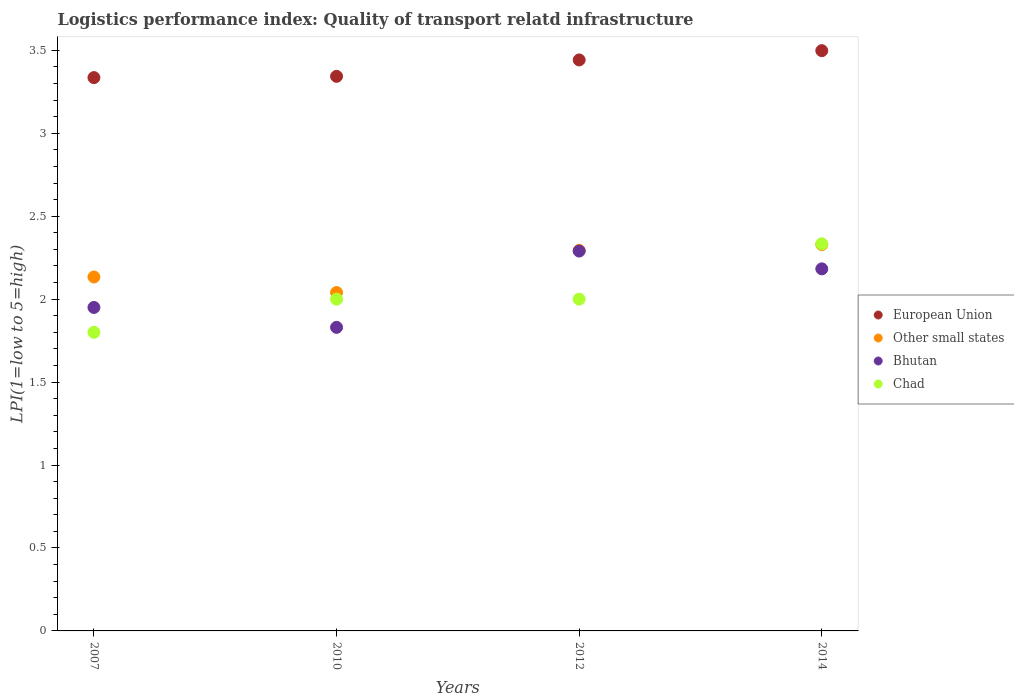How many different coloured dotlines are there?
Your answer should be very brief. 4. What is the logistics performance index in European Union in 2014?
Your answer should be compact. 3.5. Across all years, what is the maximum logistics performance index in Chad?
Keep it short and to the point. 2.33. In which year was the logistics performance index in Bhutan maximum?
Give a very brief answer. 2012. In which year was the logistics performance index in Bhutan minimum?
Provide a short and direct response. 2010. What is the total logistics performance index in European Union in the graph?
Your answer should be very brief. 13.62. What is the difference between the logistics performance index in Chad in 2010 and that in 2014?
Keep it short and to the point. -0.33. What is the difference between the logistics performance index in Bhutan in 2014 and the logistics performance index in Other small states in 2007?
Provide a short and direct response. 0.05. What is the average logistics performance index in Chad per year?
Offer a terse response. 2.03. In the year 2012, what is the difference between the logistics performance index in Other small states and logistics performance index in Bhutan?
Offer a very short reply. 0. What is the ratio of the logistics performance index in Other small states in 2007 to that in 2012?
Your response must be concise. 0.93. Is the logistics performance index in Bhutan in 2012 less than that in 2014?
Ensure brevity in your answer.  No. What is the difference between the highest and the second highest logistics performance index in Chad?
Keep it short and to the point. 0.33. What is the difference between the highest and the lowest logistics performance index in European Union?
Provide a succinct answer. 0.16. In how many years, is the logistics performance index in Chad greater than the average logistics performance index in Chad taken over all years?
Make the answer very short. 1. Is it the case that in every year, the sum of the logistics performance index in Chad and logistics performance index in European Union  is greater than the sum of logistics performance index in Bhutan and logistics performance index in Other small states?
Provide a short and direct response. Yes. Is the logistics performance index in European Union strictly greater than the logistics performance index in Bhutan over the years?
Your response must be concise. Yes. Is the logistics performance index in European Union strictly less than the logistics performance index in Bhutan over the years?
Make the answer very short. No. How many years are there in the graph?
Provide a succinct answer. 4. What is the difference between two consecutive major ticks on the Y-axis?
Keep it short and to the point. 0.5. Does the graph contain grids?
Your answer should be compact. No. How are the legend labels stacked?
Your response must be concise. Vertical. What is the title of the graph?
Provide a succinct answer. Logistics performance index: Quality of transport relatd infrastructure. What is the label or title of the Y-axis?
Ensure brevity in your answer.  LPI(1=low to 5=high). What is the LPI(1=low to 5=high) of European Union in 2007?
Your answer should be compact. 3.34. What is the LPI(1=low to 5=high) in Other small states in 2007?
Your answer should be very brief. 2.13. What is the LPI(1=low to 5=high) in Bhutan in 2007?
Make the answer very short. 1.95. What is the LPI(1=low to 5=high) of European Union in 2010?
Your response must be concise. 3.34. What is the LPI(1=low to 5=high) of Other small states in 2010?
Provide a succinct answer. 2.04. What is the LPI(1=low to 5=high) in Bhutan in 2010?
Your answer should be compact. 1.83. What is the LPI(1=low to 5=high) of Chad in 2010?
Offer a terse response. 2. What is the LPI(1=low to 5=high) of European Union in 2012?
Your answer should be very brief. 3.44. What is the LPI(1=low to 5=high) in Other small states in 2012?
Provide a short and direct response. 2.29. What is the LPI(1=low to 5=high) in Bhutan in 2012?
Your answer should be compact. 2.29. What is the LPI(1=low to 5=high) of Chad in 2012?
Give a very brief answer. 2. What is the LPI(1=low to 5=high) of European Union in 2014?
Make the answer very short. 3.5. What is the LPI(1=low to 5=high) of Other small states in 2014?
Provide a short and direct response. 2.33. What is the LPI(1=low to 5=high) of Bhutan in 2014?
Your answer should be very brief. 2.18. What is the LPI(1=low to 5=high) of Chad in 2014?
Give a very brief answer. 2.33. Across all years, what is the maximum LPI(1=low to 5=high) in European Union?
Offer a terse response. 3.5. Across all years, what is the maximum LPI(1=low to 5=high) in Other small states?
Your answer should be compact. 2.33. Across all years, what is the maximum LPI(1=low to 5=high) in Bhutan?
Provide a succinct answer. 2.29. Across all years, what is the maximum LPI(1=low to 5=high) of Chad?
Your answer should be compact. 2.33. Across all years, what is the minimum LPI(1=low to 5=high) in European Union?
Your answer should be very brief. 3.34. Across all years, what is the minimum LPI(1=low to 5=high) of Other small states?
Give a very brief answer. 2.04. Across all years, what is the minimum LPI(1=low to 5=high) in Bhutan?
Offer a very short reply. 1.83. Across all years, what is the minimum LPI(1=low to 5=high) in Chad?
Make the answer very short. 1.8. What is the total LPI(1=low to 5=high) in European Union in the graph?
Keep it short and to the point. 13.62. What is the total LPI(1=low to 5=high) of Other small states in the graph?
Keep it short and to the point. 8.8. What is the total LPI(1=low to 5=high) in Bhutan in the graph?
Offer a very short reply. 8.25. What is the total LPI(1=low to 5=high) in Chad in the graph?
Your answer should be compact. 8.13. What is the difference between the LPI(1=low to 5=high) in European Union in 2007 and that in 2010?
Your answer should be very brief. -0.01. What is the difference between the LPI(1=low to 5=high) of Other small states in 2007 and that in 2010?
Offer a terse response. 0.09. What is the difference between the LPI(1=low to 5=high) of Bhutan in 2007 and that in 2010?
Your answer should be compact. 0.12. What is the difference between the LPI(1=low to 5=high) of European Union in 2007 and that in 2012?
Your answer should be compact. -0.11. What is the difference between the LPI(1=low to 5=high) in Other small states in 2007 and that in 2012?
Your answer should be very brief. -0.16. What is the difference between the LPI(1=low to 5=high) in Bhutan in 2007 and that in 2012?
Provide a succinct answer. -0.34. What is the difference between the LPI(1=low to 5=high) of European Union in 2007 and that in 2014?
Your answer should be very brief. -0.16. What is the difference between the LPI(1=low to 5=high) in Other small states in 2007 and that in 2014?
Your response must be concise. -0.2. What is the difference between the LPI(1=low to 5=high) of Bhutan in 2007 and that in 2014?
Your answer should be compact. -0.23. What is the difference between the LPI(1=low to 5=high) in Chad in 2007 and that in 2014?
Your answer should be very brief. -0.53. What is the difference between the LPI(1=low to 5=high) in European Union in 2010 and that in 2012?
Provide a short and direct response. -0.1. What is the difference between the LPI(1=low to 5=high) in Other small states in 2010 and that in 2012?
Provide a short and direct response. -0.25. What is the difference between the LPI(1=low to 5=high) in Bhutan in 2010 and that in 2012?
Offer a very short reply. -0.46. What is the difference between the LPI(1=low to 5=high) in Chad in 2010 and that in 2012?
Provide a short and direct response. 0. What is the difference between the LPI(1=low to 5=high) of European Union in 2010 and that in 2014?
Make the answer very short. -0.15. What is the difference between the LPI(1=low to 5=high) of Other small states in 2010 and that in 2014?
Keep it short and to the point. -0.29. What is the difference between the LPI(1=low to 5=high) in Bhutan in 2010 and that in 2014?
Keep it short and to the point. -0.35. What is the difference between the LPI(1=low to 5=high) of European Union in 2012 and that in 2014?
Provide a short and direct response. -0.06. What is the difference between the LPI(1=low to 5=high) of Other small states in 2012 and that in 2014?
Offer a very short reply. -0.04. What is the difference between the LPI(1=low to 5=high) of Bhutan in 2012 and that in 2014?
Provide a succinct answer. 0.11. What is the difference between the LPI(1=low to 5=high) of European Union in 2007 and the LPI(1=low to 5=high) of Other small states in 2010?
Give a very brief answer. 1.3. What is the difference between the LPI(1=low to 5=high) in European Union in 2007 and the LPI(1=low to 5=high) in Bhutan in 2010?
Provide a short and direct response. 1.51. What is the difference between the LPI(1=low to 5=high) of European Union in 2007 and the LPI(1=low to 5=high) of Chad in 2010?
Your answer should be compact. 1.34. What is the difference between the LPI(1=low to 5=high) of Other small states in 2007 and the LPI(1=low to 5=high) of Bhutan in 2010?
Your response must be concise. 0.3. What is the difference between the LPI(1=low to 5=high) in Other small states in 2007 and the LPI(1=low to 5=high) in Chad in 2010?
Keep it short and to the point. 0.13. What is the difference between the LPI(1=low to 5=high) in European Union in 2007 and the LPI(1=low to 5=high) in Other small states in 2012?
Provide a succinct answer. 1.04. What is the difference between the LPI(1=low to 5=high) in European Union in 2007 and the LPI(1=low to 5=high) in Bhutan in 2012?
Make the answer very short. 1.05. What is the difference between the LPI(1=low to 5=high) of European Union in 2007 and the LPI(1=low to 5=high) of Chad in 2012?
Offer a terse response. 1.34. What is the difference between the LPI(1=low to 5=high) in Other small states in 2007 and the LPI(1=low to 5=high) in Bhutan in 2012?
Provide a short and direct response. -0.16. What is the difference between the LPI(1=low to 5=high) of Other small states in 2007 and the LPI(1=low to 5=high) of Chad in 2012?
Offer a terse response. 0.13. What is the difference between the LPI(1=low to 5=high) of European Union in 2007 and the LPI(1=low to 5=high) of Other small states in 2014?
Keep it short and to the point. 1.01. What is the difference between the LPI(1=low to 5=high) of European Union in 2007 and the LPI(1=low to 5=high) of Bhutan in 2014?
Your answer should be compact. 1.15. What is the difference between the LPI(1=low to 5=high) of Other small states in 2007 and the LPI(1=low to 5=high) of Bhutan in 2014?
Your answer should be compact. -0.05. What is the difference between the LPI(1=low to 5=high) of Other small states in 2007 and the LPI(1=low to 5=high) of Chad in 2014?
Provide a short and direct response. -0.2. What is the difference between the LPI(1=low to 5=high) in Bhutan in 2007 and the LPI(1=low to 5=high) in Chad in 2014?
Give a very brief answer. -0.38. What is the difference between the LPI(1=low to 5=high) of European Union in 2010 and the LPI(1=low to 5=high) of Other small states in 2012?
Offer a very short reply. 1.05. What is the difference between the LPI(1=low to 5=high) of European Union in 2010 and the LPI(1=low to 5=high) of Bhutan in 2012?
Your answer should be compact. 1.05. What is the difference between the LPI(1=low to 5=high) of European Union in 2010 and the LPI(1=low to 5=high) of Chad in 2012?
Ensure brevity in your answer.  1.34. What is the difference between the LPI(1=low to 5=high) of Bhutan in 2010 and the LPI(1=low to 5=high) of Chad in 2012?
Give a very brief answer. -0.17. What is the difference between the LPI(1=low to 5=high) in European Union in 2010 and the LPI(1=low to 5=high) in Other small states in 2014?
Your answer should be very brief. 1.01. What is the difference between the LPI(1=low to 5=high) in European Union in 2010 and the LPI(1=low to 5=high) in Bhutan in 2014?
Give a very brief answer. 1.16. What is the difference between the LPI(1=low to 5=high) of European Union in 2010 and the LPI(1=low to 5=high) of Chad in 2014?
Offer a very short reply. 1.01. What is the difference between the LPI(1=low to 5=high) of Other small states in 2010 and the LPI(1=low to 5=high) of Bhutan in 2014?
Your answer should be compact. -0.14. What is the difference between the LPI(1=low to 5=high) in Other small states in 2010 and the LPI(1=low to 5=high) in Chad in 2014?
Provide a short and direct response. -0.29. What is the difference between the LPI(1=low to 5=high) in Bhutan in 2010 and the LPI(1=low to 5=high) in Chad in 2014?
Ensure brevity in your answer.  -0.5. What is the difference between the LPI(1=low to 5=high) in European Union in 2012 and the LPI(1=low to 5=high) in Other small states in 2014?
Your response must be concise. 1.11. What is the difference between the LPI(1=low to 5=high) in European Union in 2012 and the LPI(1=low to 5=high) in Bhutan in 2014?
Provide a succinct answer. 1.26. What is the difference between the LPI(1=low to 5=high) of European Union in 2012 and the LPI(1=low to 5=high) of Chad in 2014?
Your response must be concise. 1.11. What is the difference between the LPI(1=low to 5=high) in Other small states in 2012 and the LPI(1=low to 5=high) in Bhutan in 2014?
Offer a terse response. 0.11. What is the difference between the LPI(1=low to 5=high) in Other small states in 2012 and the LPI(1=low to 5=high) in Chad in 2014?
Offer a terse response. -0.04. What is the difference between the LPI(1=low to 5=high) of Bhutan in 2012 and the LPI(1=low to 5=high) of Chad in 2014?
Your response must be concise. -0.04. What is the average LPI(1=low to 5=high) in European Union per year?
Provide a short and direct response. 3.4. What is the average LPI(1=low to 5=high) in Other small states per year?
Give a very brief answer. 2.2. What is the average LPI(1=low to 5=high) of Bhutan per year?
Make the answer very short. 2.06. What is the average LPI(1=low to 5=high) of Chad per year?
Your response must be concise. 2.03. In the year 2007, what is the difference between the LPI(1=low to 5=high) of European Union and LPI(1=low to 5=high) of Other small states?
Your answer should be compact. 1.2. In the year 2007, what is the difference between the LPI(1=low to 5=high) of European Union and LPI(1=low to 5=high) of Bhutan?
Your answer should be very brief. 1.39. In the year 2007, what is the difference between the LPI(1=low to 5=high) in European Union and LPI(1=low to 5=high) in Chad?
Provide a succinct answer. 1.54. In the year 2007, what is the difference between the LPI(1=low to 5=high) in Other small states and LPI(1=low to 5=high) in Bhutan?
Provide a succinct answer. 0.18. In the year 2007, what is the difference between the LPI(1=low to 5=high) in Other small states and LPI(1=low to 5=high) in Chad?
Ensure brevity in your answer.  0.33. In the year 2010, what is the difference between the LPI(1=low to 5=high) in European Union and LPI(1=low to 5=high) in Other small states?
Offer a terse response. 1.3. In the year 2010, what is the difference between the LPI(1=low to 5=high) of European Union and LPI(1=low to 5=high) of Bhutan?
Offer a very short reply. 1.51. In the year 2010, what is the difference between the LPI(1=low to 5=high) in European Union and LPI(1=low to 5=high) in Chad?
Offer a terse response. 1.34. In the year 2010, what is the difference between the LPI(1=low to 5=high) in Other small states and LPI(1=low to 5=high) in Bhutan?
Ensure brevity in your answer.  0.21. In the year 2010, what is the difference between the LPI(1=low to 5=high) in Bhutan and LPI(1=low to 5=high) in Chad?
Your answer should be very brief. -0.17. In the year 2012, what is the difference between the LPI(1=low to 5=high) in European Union and LPI(1=low to 5=high) in Other small states?
Offer a very short reply. 1.15. In the year 2012, what is the difference between the LPI(1=low to 5=high) in European Union and LPI(1=low to 5=high) in Bhutan?
Give a very brief answer. 1.15. In the year 2012, what is the difference between the LPI(1=low to 5=high) in European Union and LPI(1=low to 5=high) in Chad?
Make the answer very short. 1.44. In the year 2012, what is the difference between the LPI(1=low to 5=high) in Other small states and LPI(1=low to 5=high) in Bhutan?
Ensure brevity in your answer.  0. In the year 2012, what is the difference between the LPI(1=low to 5=high) of Other small states and LPI(1=low to 5=high) of Chad?
Your response must be concise. 0.29. In the year 2012, what is the difference between the LPI(1=low to 5=high) in Bhutan and LPI(1=low to 5=high) in Chad?
Your answer should be compact. 0.29. In the year 2014, what is the difference between the LPI(1=low to 5=high) of European Union and LPI(1=low to 5=high) of Other small states?
Ensure brevity in your answer.  1.17. In the year 2014, what is the difference between the LPI(1=low to 5=high) in European Union and LPI(1=low to 5=high) in Bhutan?
Give a very brief answer. 1.32. In the year 2014, what is the difference between the LPI(1=low to 5=high) in European Union and LPI(1=low to 5=high) in Chad?
Make the answer very short. 1.16. In the year 2014, what is the difference between the LPI(1=low to 5=high) of Other small states and LPI(1=low to 5=high) of Bhutan?
Offer a terse response. 0.15. In the year 2014, what is the difference between the LPI(1=low to 5=high) in Other small states and LPI(1=low to 5=high) in Chad?
Offer a terse response. -0. In the year 2014, what is the difference between the LPI(1=low to 5=high) in Bhutan and LPI(1=low to 5=high) in Chad?
Provide a succinct answer. -0.15. What is the ratio of the LPI(1=low to 5=high) of Other small states in 2007 to that in 2010?
Ensure brevity in your answer.  1.05. What is the ratio of the LPI(1=low to 5=high) of Bhutan in 2007 to that in 2010?
Offer a very short reply. 1.07. What is the ratio of the LPI(1=low to 5=high) in European Union in 2007 to that in 2012?
Your response must be concise. 0.97. What is the ratio of the LPI(1=low to 5=high) of Other small states in 2007 to that in 2012?
Keep it short and to the point. 0.93. What is the ratio of the LPI(1=low to 5=high) in Bhutan in 2007 to that in 2012?
Ensure brevity in your answer.  0.85. What is the ratio of the LPI(1=low to 5=high) in European Union in 2007 to that in 2014?
Make the answer very short. 0.95. What is the ratio of the LPI(1=low to 5=high) of Other small states in 2007 to that in 2014?
Ensure brevity in your answer.  0.92. What is the ratio of the LPI(1=low to 5=high) of Bhutan in 2007 to that in 2014?
Offer a terse response. 0.89. What is the ratio of the LPI(1=low to 5=high) of Chad in 2007 to that in 2014?
Offer a terse response. 0.77. What is the ratio of the LPI(1=low to 5=high) of European Union in 2010 to that in 2012?
Offer a terse response. 0.97. What is the ratio of the LPI(1=low to 5=high) in Other small states in 2010 to that in 2012?
Offer a very short reply. 0.89. What is the ratio of the LPI(1=low to 5=high) of Bhutan in 2010 to that in 2012?
Make the answer very short. 0.8. What is the ratio of the LPI(1=low to 5=high) of European Union in 2010 to that in 2014?
Keep it short and to the point. 0.96. What is the ratio of the LPI(1=low to 5=high) of Other small states in 2010 to that in 2014?
Provide a short and direct response. 0.88. What is the ratio of the LPI(1=low to 5=high) in Bhutan in 2010 to that in 2014?
Provide a short and direct response. 0.84. What is the ratio of the LPI(1=low to 5=high) of Chad in 2010 to that in 2014?
Your answer should be compact. 0.86. What is the ratio of the LPI(1=low to 5=high) of European Union in 2012 to that in 2014?
Provide a short and direct response. 0.98. What is the ratio of the LPI(1=low to 5=high) in Other small states in 2012 to that in 2014?
Your response must be concise. 0.98. What is the ratio of the LPI(1=low to 5=high) of Bhutan in 2012 to that in 2014?
Your answer should be very brief. 1.05. What is the ratio of the LPI(1=low to 5=high) in Chad in 2012 to that in 2014?
Provide a succinct answer. 0.86. What is the difference between the highest and the second highest LPI(1=low to 5=high) in European Union?
Offer a very short reply. 0.06. What is the difference between the highest and the second highest LPI(1=low to 5=high) in Other small states?
Your answer should be very brief. 0.04. What is the difference between the highest and the second highest LPI(1=low to 5=high) in Bhutan?
Your response must be concise. 0.11. What is the difference between the highest and the second highest LPI(1=low to 5=high) in Chad?
Provide a succinct answer. 0.33. What is the difference between the highest and the lowest LPI(1=low to 5=high) of European Union?
Provide a succinct answer. 0.16. What is the difference between the highest and the lowest LPI(1=low to 5=high) in Other small states?
Make the answer very short. 0.29. What is the difference between the highest and the lowest LPI(1=low to 5=high) of Bhutan?
Give a very brief answer. 0.46. What is the difference between the highest and the lowest LPI(1=low to 5=high) of Chad?
Offer a terse response. 0.53. 